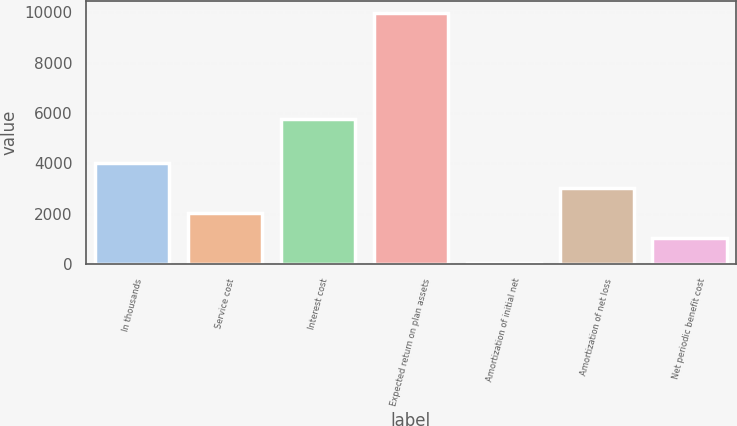Convert chart. <chart><loc_0><loc_0><loc_500><loc_500><bar_chart><fcel>In thousands<fcel>Service cost<fcel>Interest cost<fcel>Expected return on plan assets<fcel>Amortization of initial net<fcel>Amortization of net loss<fcel>Net periodic benefit cost<nl><fcel>4025<fcel>2043<fcel>5774<fcel>9971<fcel>61<fcel>3034<fcel>1052<nl></chart> 